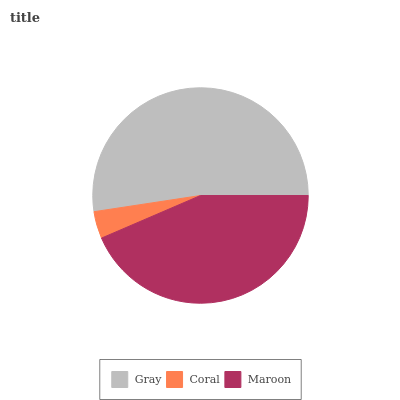Is Coral the minimum?
Answer yes or no. Yes. Is Gray the maximum?
Answer yes or no. Yes. Is Maroon the minimum?
Answer yes or no. No. Is Maroon the maximum?
Answer yes or no. No. Is Maroon greater than Coral?
Answer yes or no. Yes. Is Coral less than Maroon?
Answer yes or no. Yes. Is Coral greater than Maroon?
Answer yes or no. No. Is Maroon less than Coral?
Answer yes or no. No. Is Maroon the high median?
Answer yes or no. Yes. Is Maroon the low median?
Answer yes or no. Yes. Is Coral the high median?
Answer yes or no. No. Is Coral the low median?
Answer yes or no. No. 